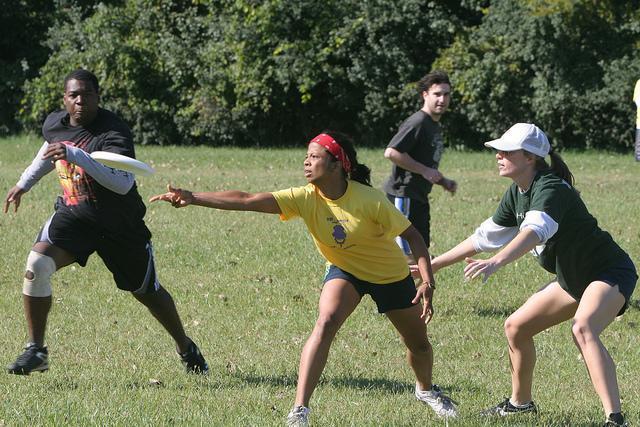How many people are there?
Give a very brief answer. 4. How many people are visible?
Give a very brief answer. 4. 